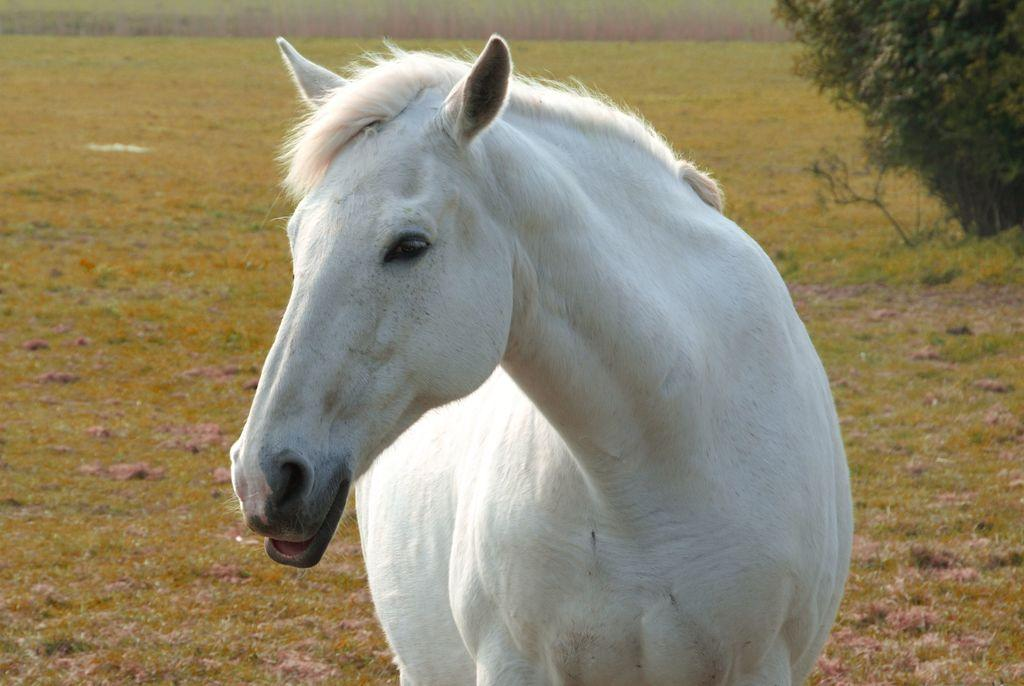What animal is present in the image? There is a horse in the image. What colors can be seen on the horse? The horse is white and black in color. Where is the horse located in the image? The horse is standing on the road. What type of vegetation is visible on the ground in the image? There is grass on the ground in the image. What other object can be seen in the image? There is a tree in the image. What is the color of the tree? The tree is green in color. What type of pin is holding the horse's tail in the image? There is no pin present in the image, and the horse's tail is not being held by any object. 